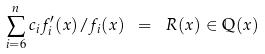<formula> <loc_0><loc_0><loc_500><loc_500>\sum _ { i = 6 } ^ { n } c _ { i } f _ { i } ^ { \prime } ( x ) / f _ { i } ( x ) \ = \ R ( x ) \in \mathbb { Q } ( x )</formula> 